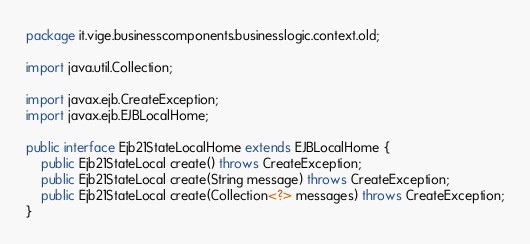Convert code to text. <code><loc_0><loc_0><loc_500><loc_500><_Java_>package it.vige.businesscomponents.businesslogic.context.old;

import java.util.Collection;

import javax.ejb.CreateException;
import javax.ejb.EJBLocalHome;

public interface Ejb21StateLocalHome extends EJBLocalHome {
	public Ejb21StateLocal create() throws CreateException;
	public Ejb21StateLocal create(String message) throws CreateException;
	public Ejb21StateLocal create(Collection<?> messages) throws CreateException;
}
</code> 